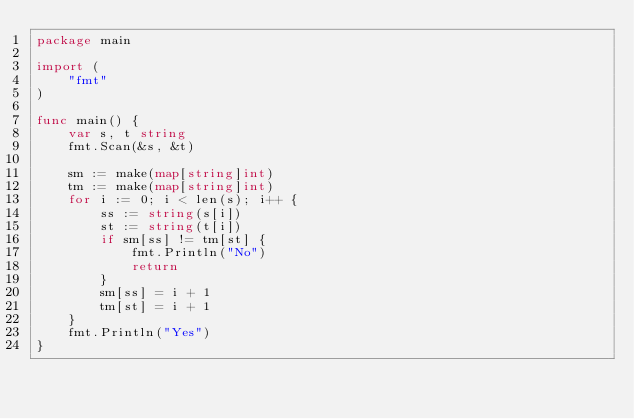<code> <loc_0><loc_0><loc_500><loc_500><_Go_>package main

import (
	"fmt"
)

func main() {
	var s, t string
	fmt.Scan(&s, &t)

	sm := make(map[string]int)
	tm := make(map[string]int)
	for i := 0; i < len(s); i++ {
		ss := string(s[i])
		st := string(t[i])
		if sm[ss] != tm[st] {
			fmt.Println("No")
			return
		}
		sm[ss] = i + 1
		tm[st] = i + 1
	}
	fmt.Println("Yes")
}
</code> 